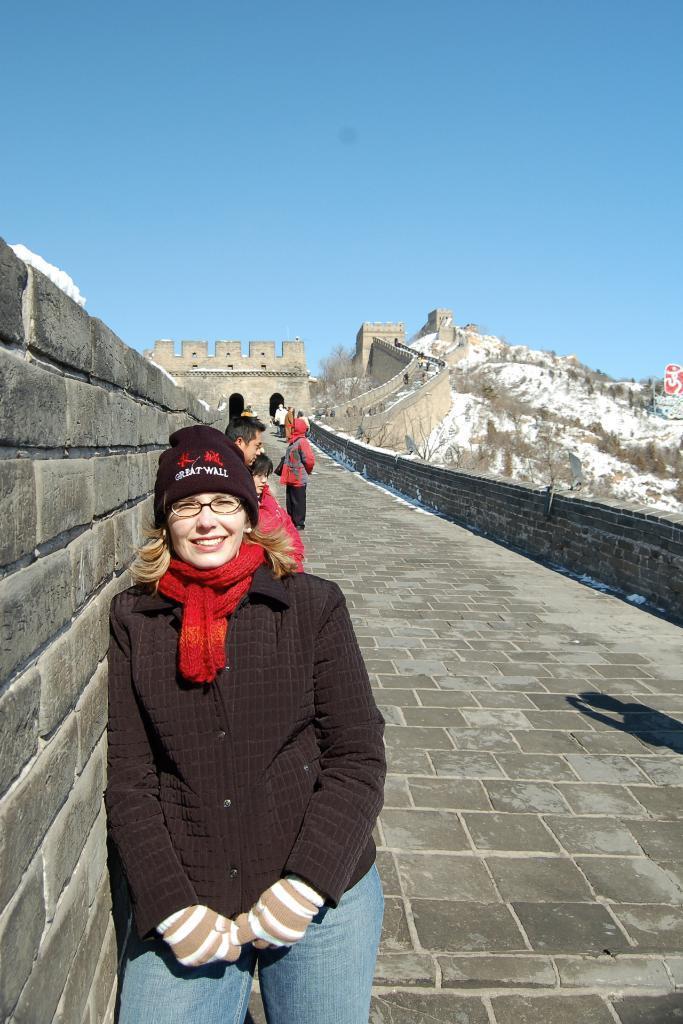Describe this image in one or two sentences. Here we can see few persons on the road. She has spectacles and she is smiling. Here we can see wall, fort, and a board. In the background there is sky. 